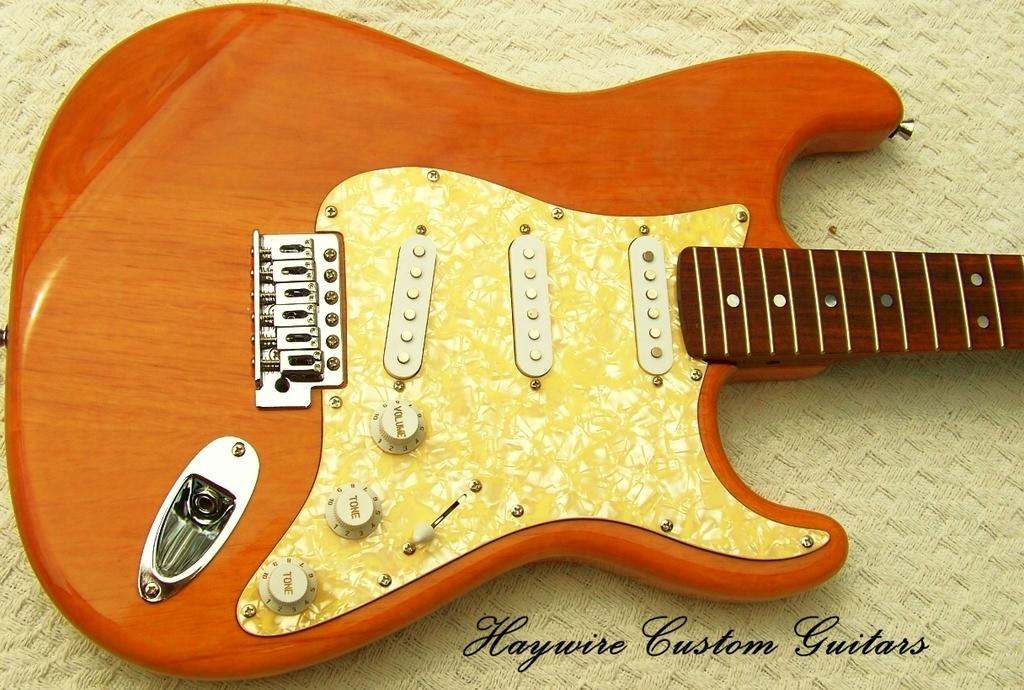What musical instrument is present in the image? There is a guitar in the image. Can you see any icicles hanging from the guitar in the image? There are no icicles present in the image, as it features a guitar without any ice formations. 